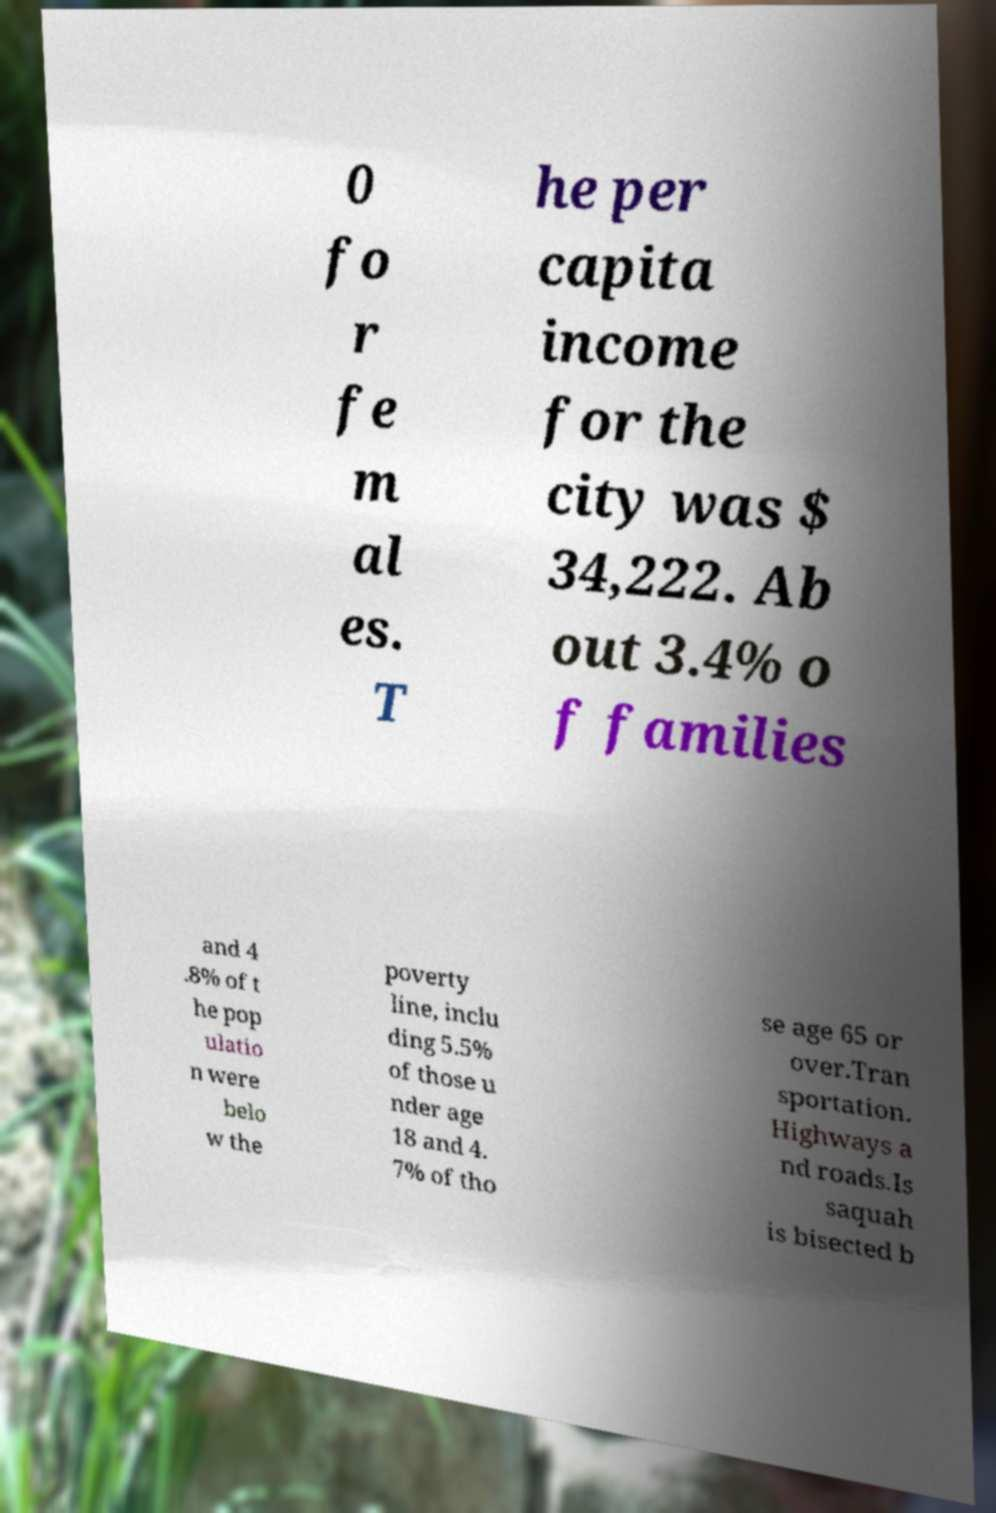Please identify and transcribe the text found in this image. 0 fo r fe m al es. T he per capita income for the city was $ 34,222. Ab out 3.4% o f families and 4 .8% of t he pop ulatio n were belo w the poverty line, inclu ding 5.5% of those u nder age 18 and 4. 7% of tho se age 65 or over.Tran sportation. Highways a nd roads.Is saquah is bisected b 